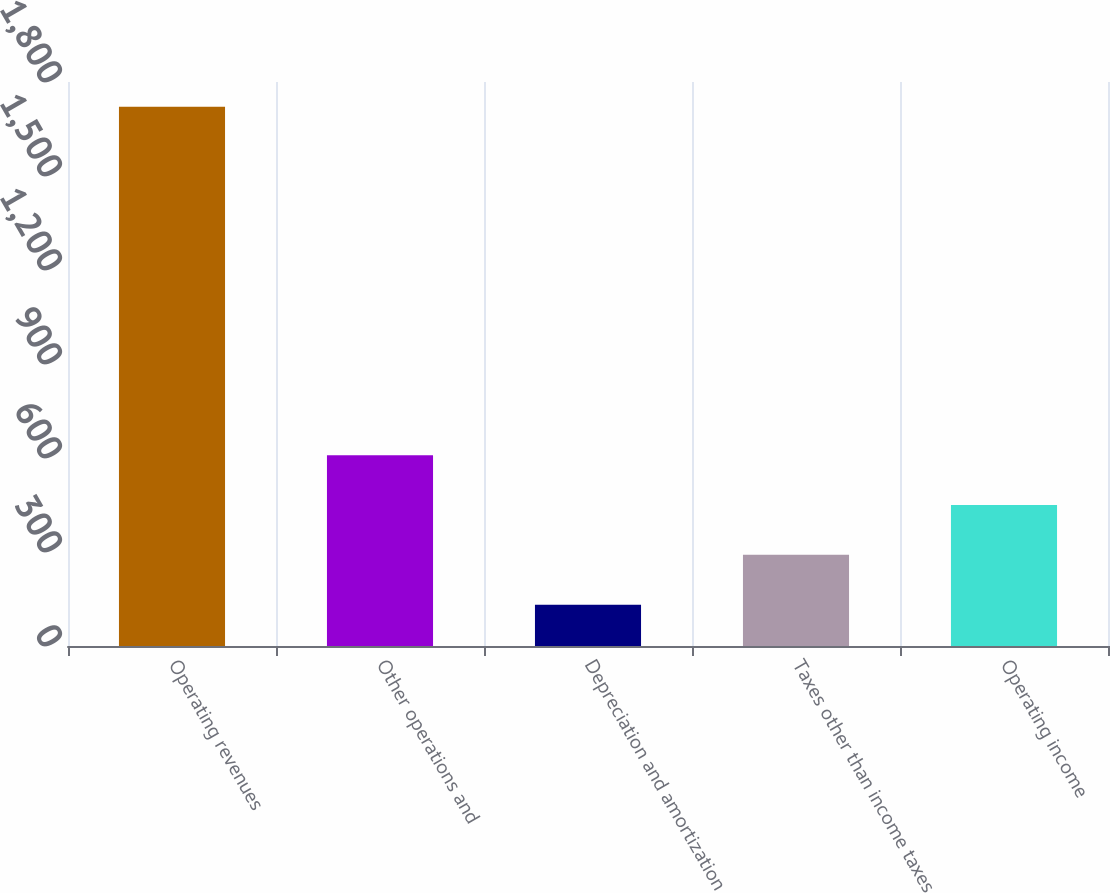Convert chart. <chart><loc_0><loc_0><loc_500><loc_500><bar_chart><fcel>Operating revenues<fcel>Other operations and<fcel>Depreciation and amortization<fcel>Taxes other than income taxes<fcel>Operating income<nl><fcel>1721<fcel>608.7<fcel>132<fcel>290.9<fcel>449.8<nl></chart> 